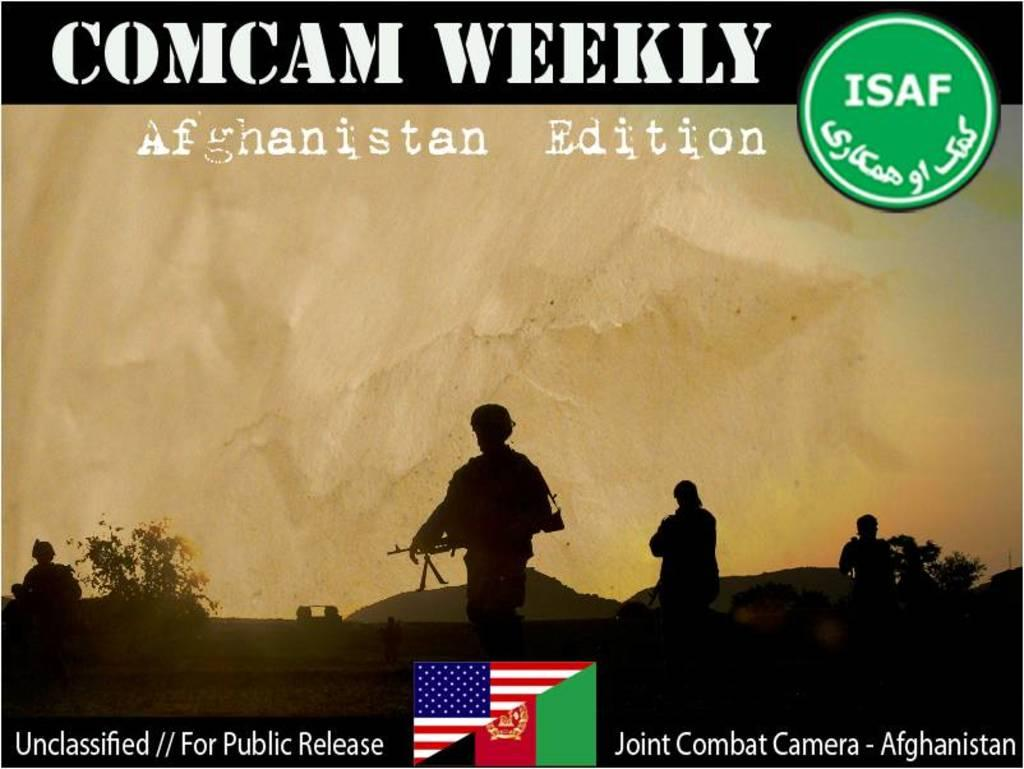<image>
Present a compact description of the photo's key features. The combat camera shows some of the action in Afghanistan. 